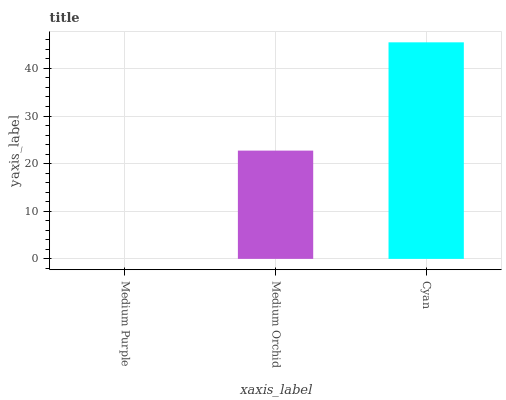Is Medium Purple the minimum?
Answer yes or no. Yes. Is Cyan the maximum?
Answer yes or no. Yes. Is Medium Orchid the minimum?
Answer yes or no. No. Is Medium Orchid the maximum?
Answer yes or no. No. Is Medium Orchid greater than Medium Purple?
Answer yes or no. Yes. Is Medium Purple less than Medium Orchid?
Answer yes or no. Yes. Is Medium Purple greater than Medium Orchid?
Answer yes or no. No. Is Medium Orchid less than Medium Purple?
Answer yes or no. No. Is Medium Orchid the high median?
Answer yes or no. Yes. Is Medium Orchid the low median?
Answer yes or no. Yes. Is Medium Purple the high median?
Answer yes or no. No. Is Cyan the low median?
Answer yes or no. No. 